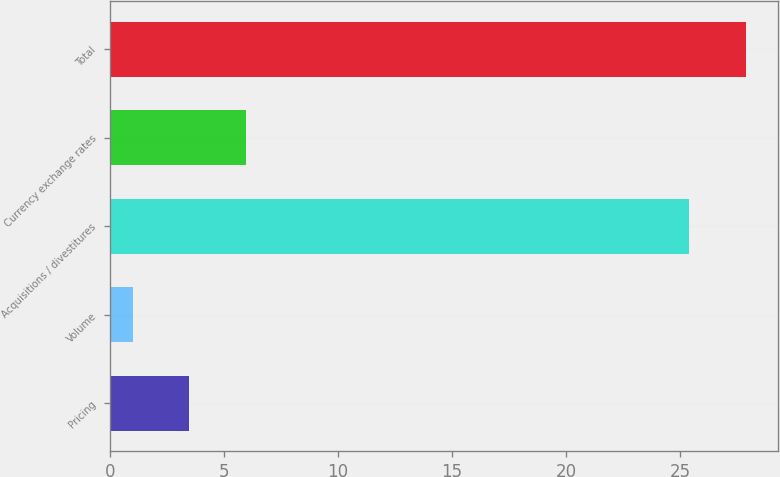Convert chart. <chart><loc_0><loc_0><loc_500><loc_500><bar_chart><fcel>Pricing<fcel>Volume<fcel>Acquisitions / divestitures<fcel>Currency exchange rates<fcel>Total<nl><fcel>3.48<fcel>1<fcel>25.4<fcel>5.96<fcel>27.88<nl></chart> 